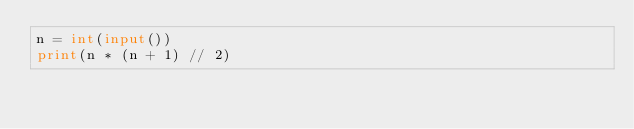Convert code to text. <code><loc_0><loc_0><loc_500><loc_500><_Python_>n = int(input())
print(n * (n + 1) // 2)</code> 